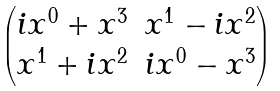<formula> <loc_0><loc_0><loc_500><loc_500>\begin{pmatrix} i x ^ { 0 } + x ^ { 3 } & x ^ { 1 } - i x ^ { 2 } \\ x ^ { 1 } + i x ^ { 2 } & i x ^ { 0 } - x ^ { 3 } \end{pmatrix}</formula> 